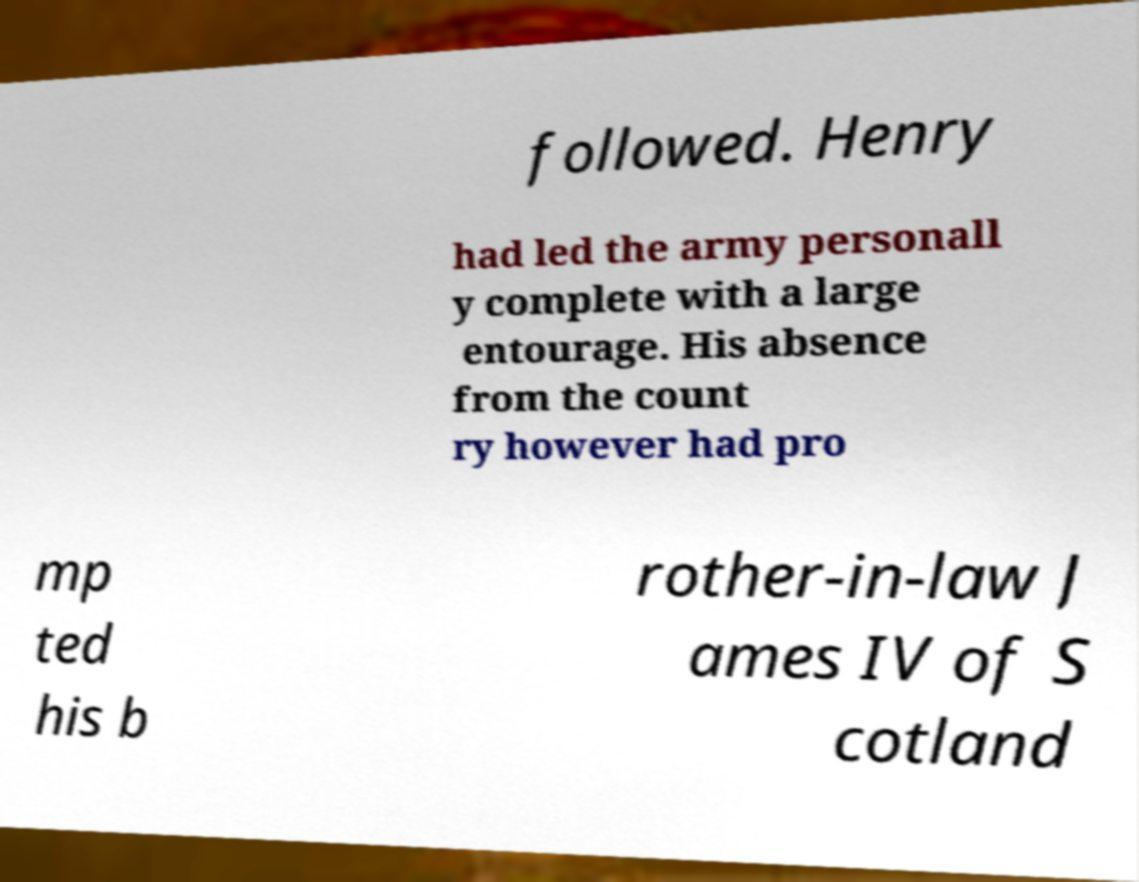Could you assist in decoding the text presented in this image and type it out clearly? followed. Henry had led the army personall y complete with a large entourage. His absence from the count ry however had pro mp ted his b rother-in-law J ames IV of S cotland 